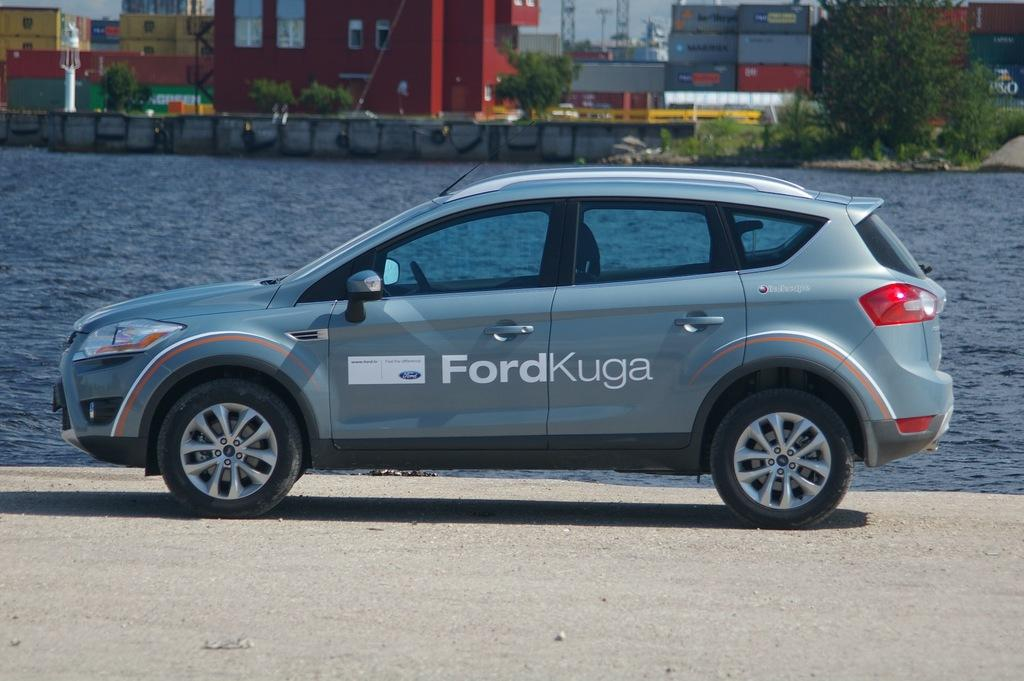What is the main subject in the center of the image? There is a car in the center of the image. What can be seen at the bottom of the image? There is a walkway at the bottom of the image. What is visible in the background of the image? There is a river, buildings, trees, and towers in the background of the image. Can you see a bear walking along the river in the image? There is no bear present in the image, and no animals are visible. 